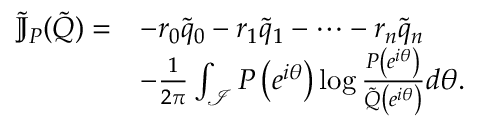Convert formula to latex. <formula><loc_0><loc_0><loc_500><loc_500>\begin{array} { r l } { \tilde { \mathbb { J } } _ { P } ( \tilde { Q } ) = } & { - r _ { 0 } \tilde { q } _ { 0 } - r _ { 1 } \tilde { q } _ { 1 } - \cdots - r _ { n } \tilde { q } _ { n } } \\ & { - \frac { 1 } { 2 \pi } \int _ { \mathcal { I } } P \left ( e ^ { i \theta } \right ) \log \frac { P \left ( e ^ { i \theta } \right ) } { \tilde { Q } \left ( e ^ { i \theta } \right ) } d \theta . } \end{array}</formula> 